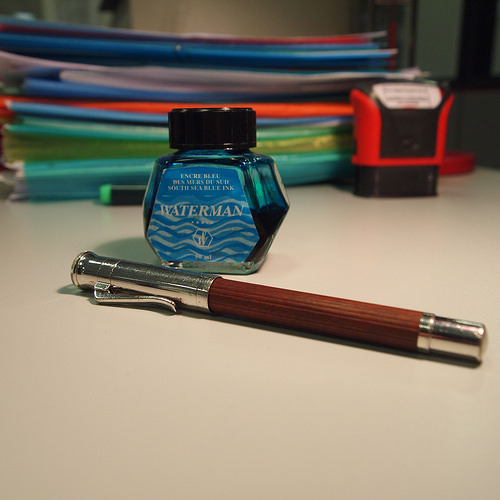<image>
Is the ink behind the pen? Yes. From this viewpoint, the ink is positioned behind the pen, with the pen partially or fully occluding the ink. Where is the ink bottle in relation to the pen? Is it in front of the pen? No. The ink bottle is not in front of the pen. The spatial positioning shows a different relationship between these objects. 